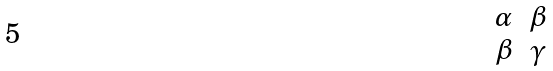Convert formula to latex. <formula><loc_0><loc_0><loc_500><loc_500>\begin{matrix} \alpha & \beta \\ \beta & \gamma \\ \end{matrix}</formula> 